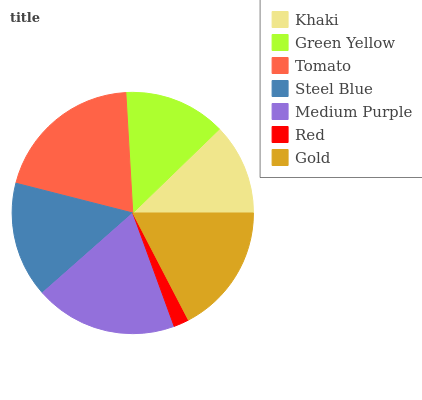Is Red the minimum?
Answer yes or no. Yes. Is Tomato the maximum?
Answer yes or no. Yes. Is Green Yellow the minimum?
Answer yes or no. No. Is Green Yellow the maximum?
Answer yes or no. No. Is Green Yellow greater than Khaki?
Answer yes or no. Yes. Is Khaki less than Green Yellow?
Answer yes or no. Yes. Is Khaki greater than Green Yellow?
Answer yes or no. No. Is Green Yellow less than Khaki?
Answer yes or no. No. Is Steel Blue the high median?
Answer yes or no. Yes. Is Steel Blue the low median?
Answer yes or no. Yes. Is Tomato the high median?
Answer yes or no. No. Is Khaki the low median?
Answer yes or no. No. 